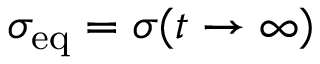<formula> <loc_0><loc_0><loc_500><loc_500>\sigma _ { e q } = \sigma ( t \to \infty )</formula> 